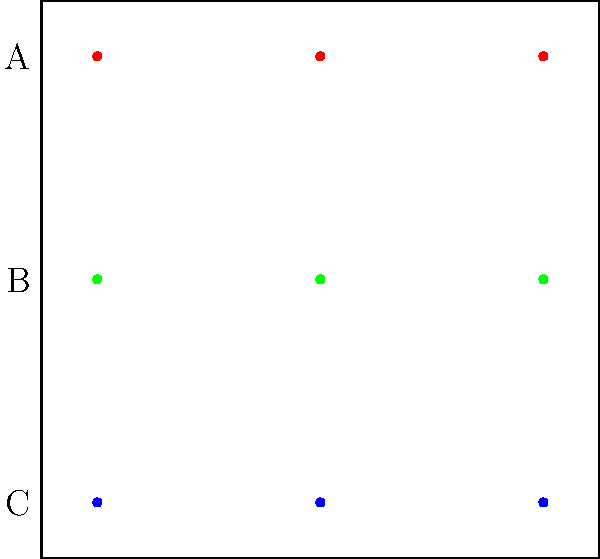In a film shot composition, three actors (represented by colored dots) are arranged in three rows (A, B, C). How many unique permutations of the actors' positions can be created while maintaining their row structure? Express your answer in terms of the order of the symmetric group $S_3$. To solve this problem, we'll follow these steps:

1) First, recognize that each row (A, B, C) contains 3 actors, and their positions within each row can be permuted.

2) The number of permutations for each row is equal to the number of permutations of 3 elements, which is 3! = 6.

3) Since we have 3 rows, and each row can be permuted independently, we use the multiplication principle.

4) The total number of permutations is therefore:
   $6 \times 6 \times 6 = 6^3 = 216$

5) Recall that the order of the symmetric group $S_3$ is 3! = 6.

6) We can express our result in terms of $|S_3|$ (the order of $S_3$):
   $216 = 6^3 = |S_3|^3$

Therefore, the number of unique permutations is $|S_3|^3$.
Answer: $|S_3|^3$ 